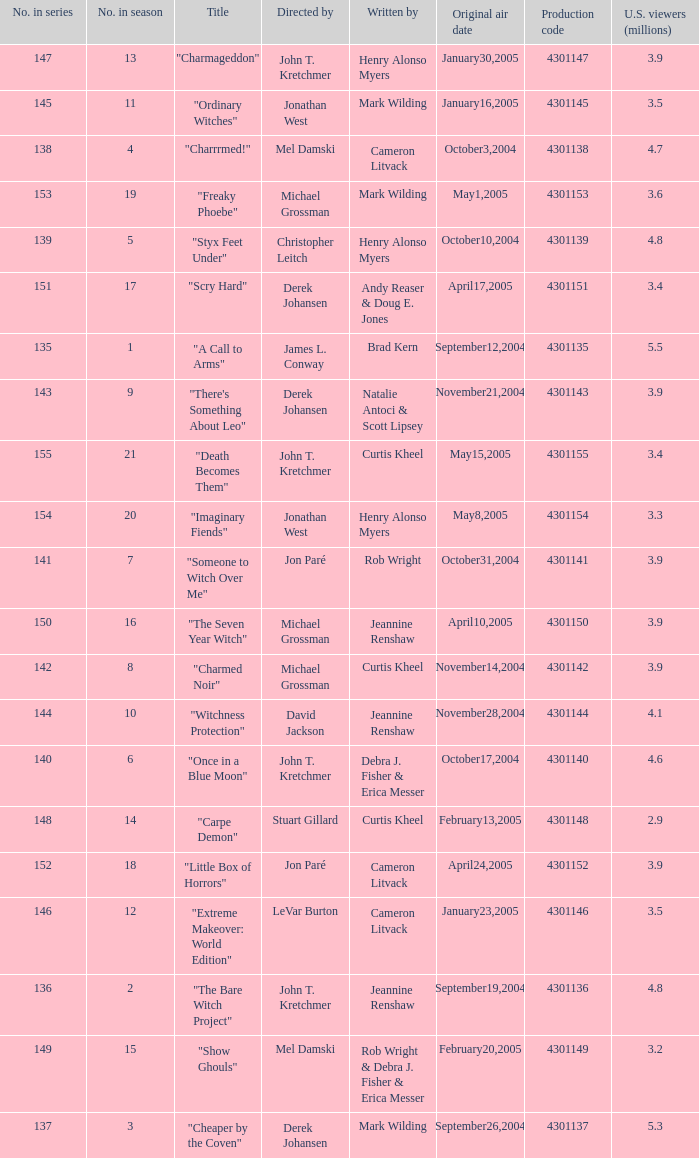What was the name of the episode that got 3.3 (millions) of u.s viewers? "Imaginary Fiends". 